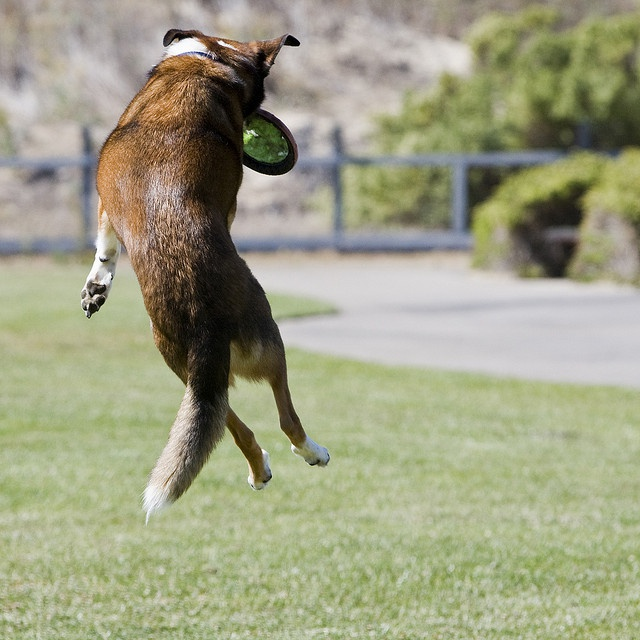Describe the objects in this image and their specific colors. I can see dog in gray, black, and olive tones and frisbee in gray, black, and darkgreen tones in this image. 